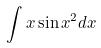<formula> <loc_0><loc_0><loc_500><loc_500>\int x \sin x ^ { 2 } d x</formula> 